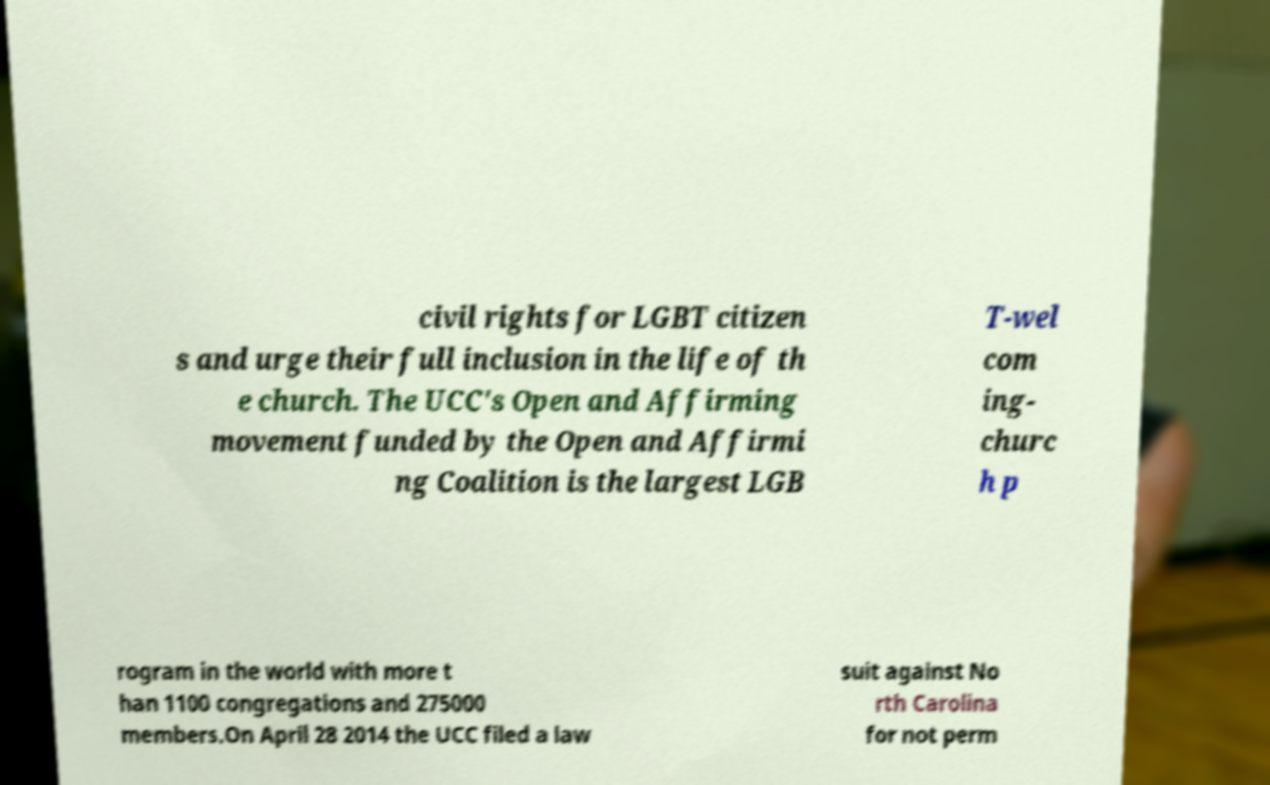Could you extract and type out the text from this image? civil rights for LGBT citizen s and urge their full inclusion in the life of th e church. The UCC's Open and Affirming movement funded by the Open and Affirmi ng Coalition is the largest LGB T-wel com ing- churc h p rogram in the world with more t han 1100 congregations and 275000 members.On April 28 2014 the UCC filed a law suit against No rth Carolina for not perm 